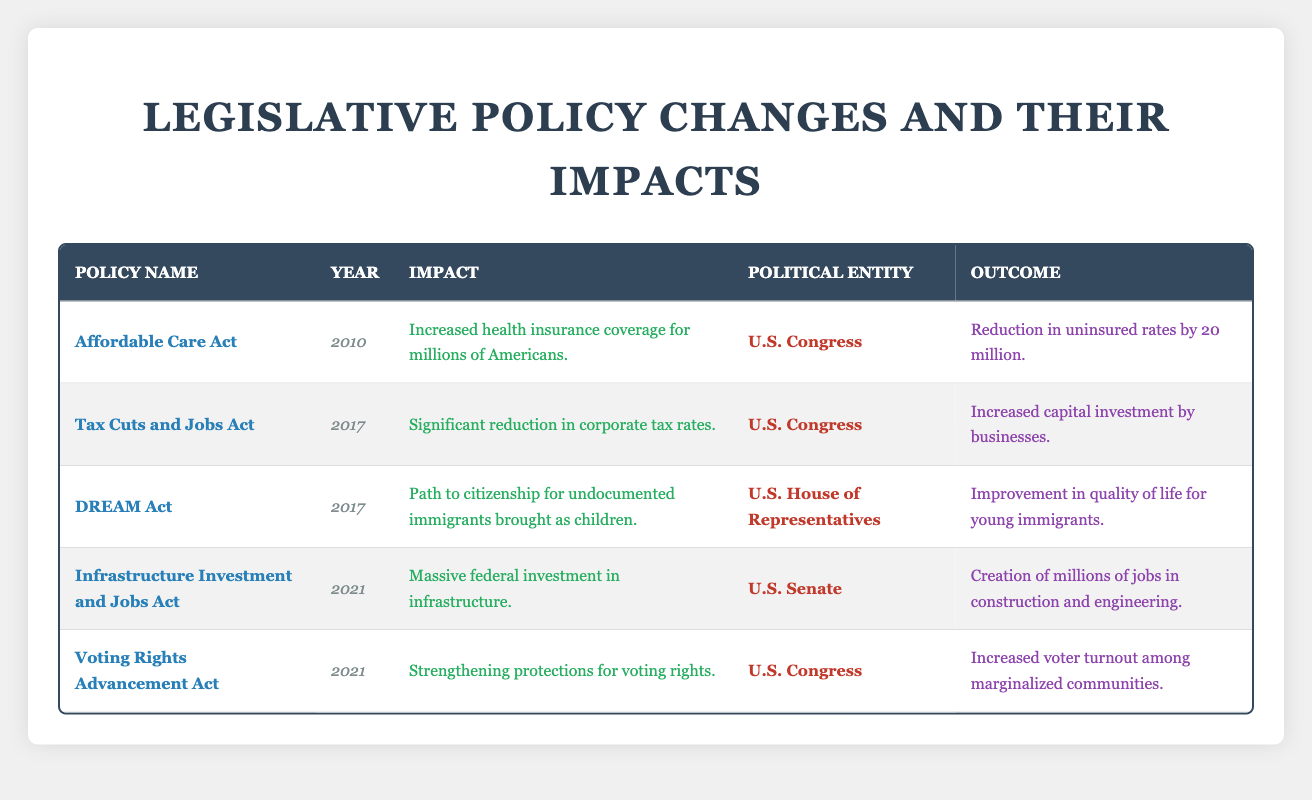What year was the Affordable Care Act enacted? The table shows the year associated with the Affordable Care Act in the 'Year' column. It is listed as 2010.
Answer: 2010 What is the primary impact of the Voting Rights Advancement Act? According to the table, the impact listed for the Voting Rights Advancement Act is the strengthening of protections for voting rights.
Answer: Strengthening protections for voting rights How many years apart were the Tax Cuts and Jobs Act and the Infrastructure Investment and Jobs Act enacted? The Tax Cuts and Jobs Act was enacted in 2017, and the Infrastructure Investment and Jobs Act was enacted in 2021. The difference between the years is 2021 - 2017, which equals 4 years.
Answer: 4 years Did the DREAM Act primarily affect corporate tax rates? The table indicates that the DREAM Act's impact relates to citizenship for undocumented immigrants, whereas corporate tax rates are specifically addressed by the Tax Cuts and Jobs Act. Thus, the answer is no.
Answer: No Which policy was passed by the U.S. Senate? The table shows that the Infrastructure Investment and Jobs Act was the only policy passed by the U.S. Senate.
Answer: Infrastructure Investment and Jobs Act How many policies listed had a social outcome related to improving quality of life or voter engagement? The Affordable Care Act, the DREAM Act, and the Voting Rights Advancement Act all mention social outcomes like reducing uninsured rates, improving quality of life, and increasing voter turnout. Thus, there are three policies with social outcomes related to quality of life or voter engagement.
Answer: 3 What is the total number of policies indicated in the table? By counting the number of entries in the table's 'Policy Name' column, there are five policies listed in total.
Answer: 5 Was there any policy aimed at increasing capital investment by businesses? The table states that the Tax Cuts and Jobs Act, enacted in 2017, had an impact of increasing capital investment by businesses. Therefore, the answer is yes.
Answer: Yes Which policy had an impact related to job creation, and what was that impact? The table indicates that the Infrastructure Investment and Jobs Act had an impact of creating millions of jobs in construction and engineering.
Answer: Infrastructure Investment and Jobs Act, creation of millions of jobs in construction and engineering 